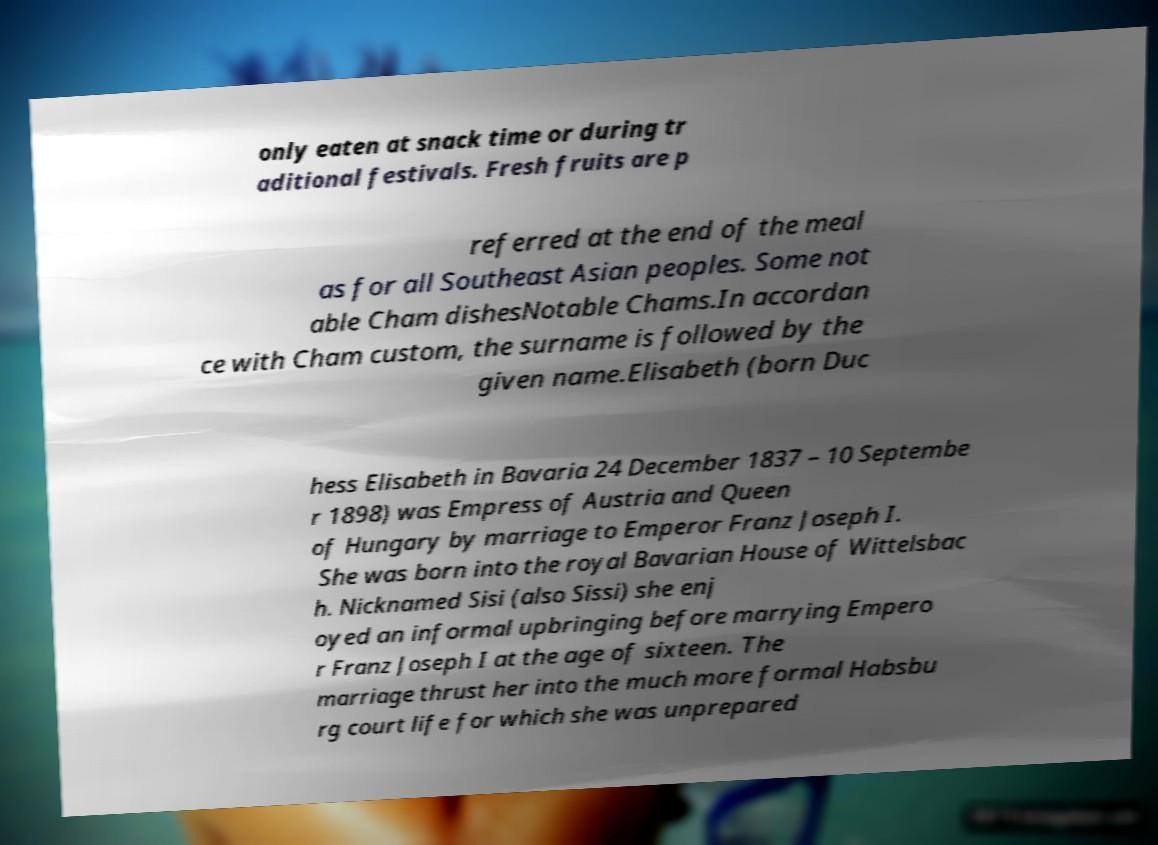I need the written content from this picture converted into text. Can you do that? only eaten at snack time or during tr aditional festivals. Fresh fruits are p referred at the end of the meal as for all Southeast Asian peoples. Some not able Cham dishesNotable Chams.In accordan ce with Cham custom, the surname is followed by the given name.Elisabeth (born Duc hess Elisabeth in Bavaria 24 December 1837 – 10 Septembe r 1898) was Empress of Austria and Queen of Hungary by marriage to Emperor Franz Joseph I. She was born into the royal Bavarian House of Wittelsbac h. Nicknamed Sisi (also Sissi) she enj oyed an informal upbringing before marrying Empero r Franz Joseph I at the age of sixteen. The marriage thrust her into the much more formal Habsbu rg court life for which she was unprepared 